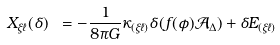<formula> <loc_0><loc_0><loc_500><loc_500>X _ { \xi \ell } ( \delta ) \ = - \frac { 1 } { 8 \pi G } \kappa _ { ( \xi \ell ) } \delta ( f ( \phi ) \mathcal { A } _ { \Delta } ) + \delta E _ { ( \xi \ell ) }</formula> 